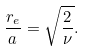Convert formula to latex. <formula><loc_0><loc_0><loc_500><loc_500>\frac { r _ { e } } { a } = \sqrt { \frac { 2 } { \nu } } .</formula> 